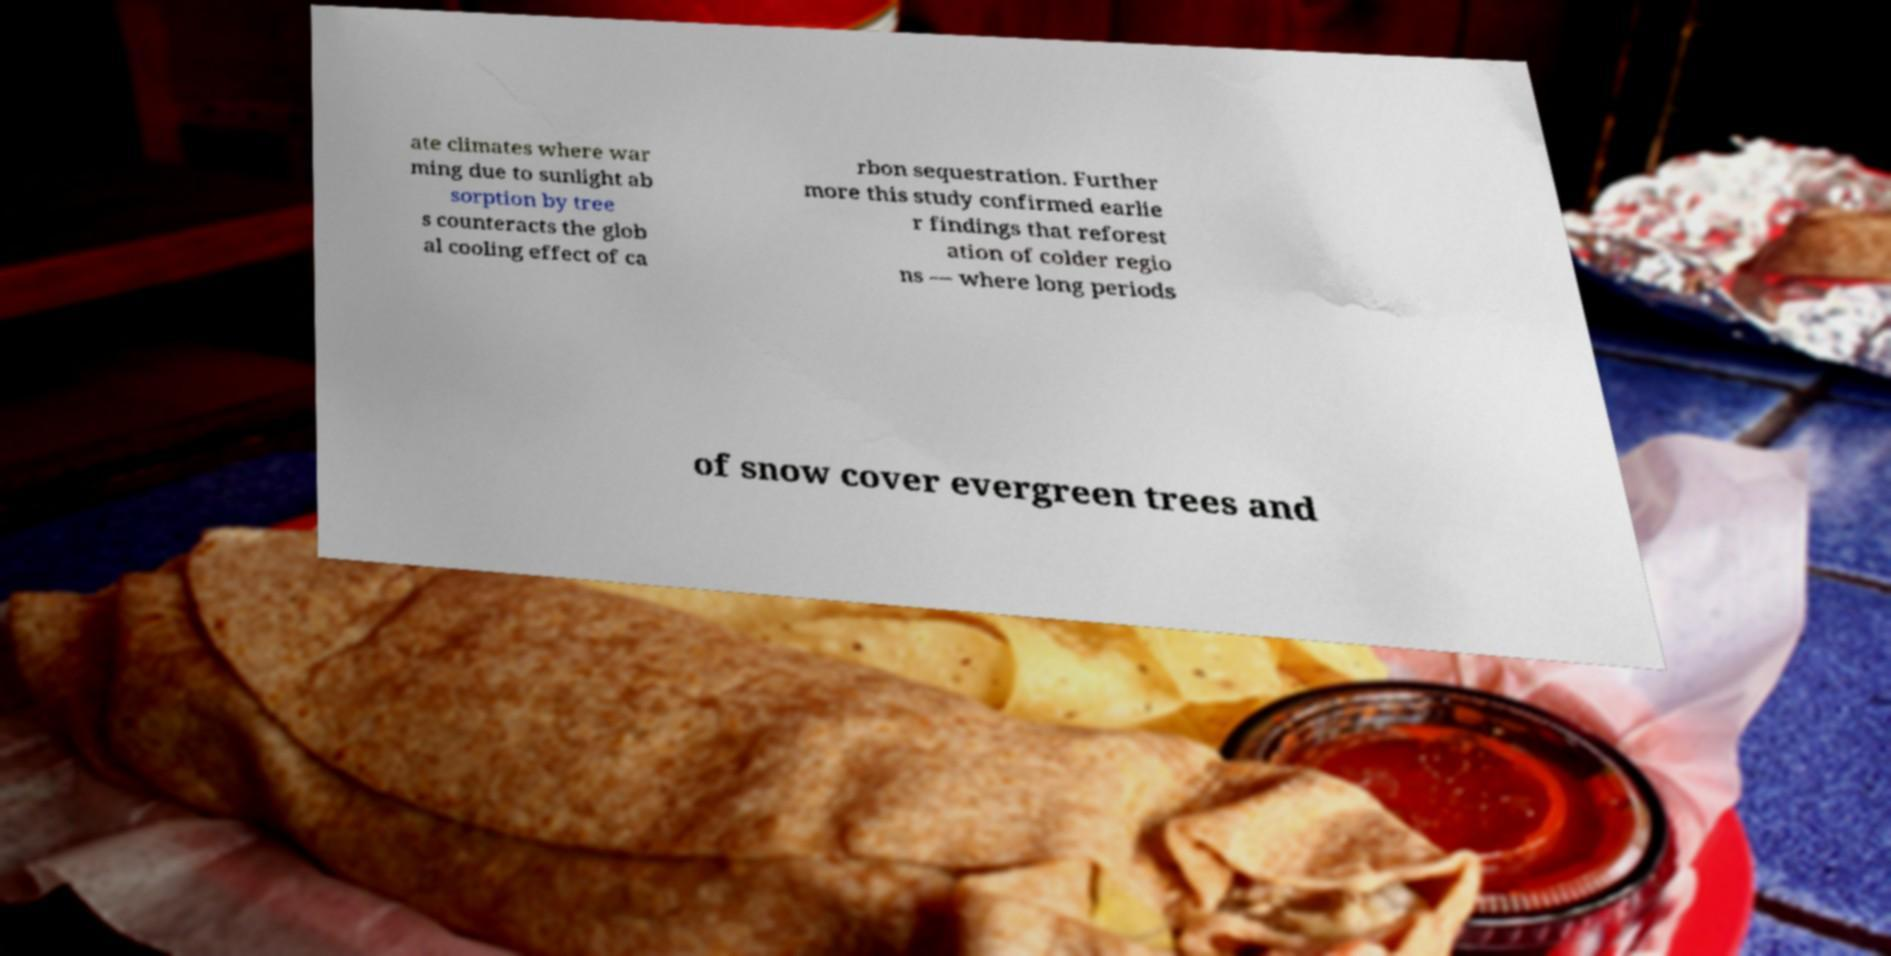Please read and relay the text visible in this image. What does it say? ate climates where war ming due to sunlight ab sorption by tree s counteracts the glob al cooling effect of ca rbon sequestration. Further more this study confirmed earlie r findings that reforest ation of colder regio ns — where long periods of snow cover evergreen trees and 